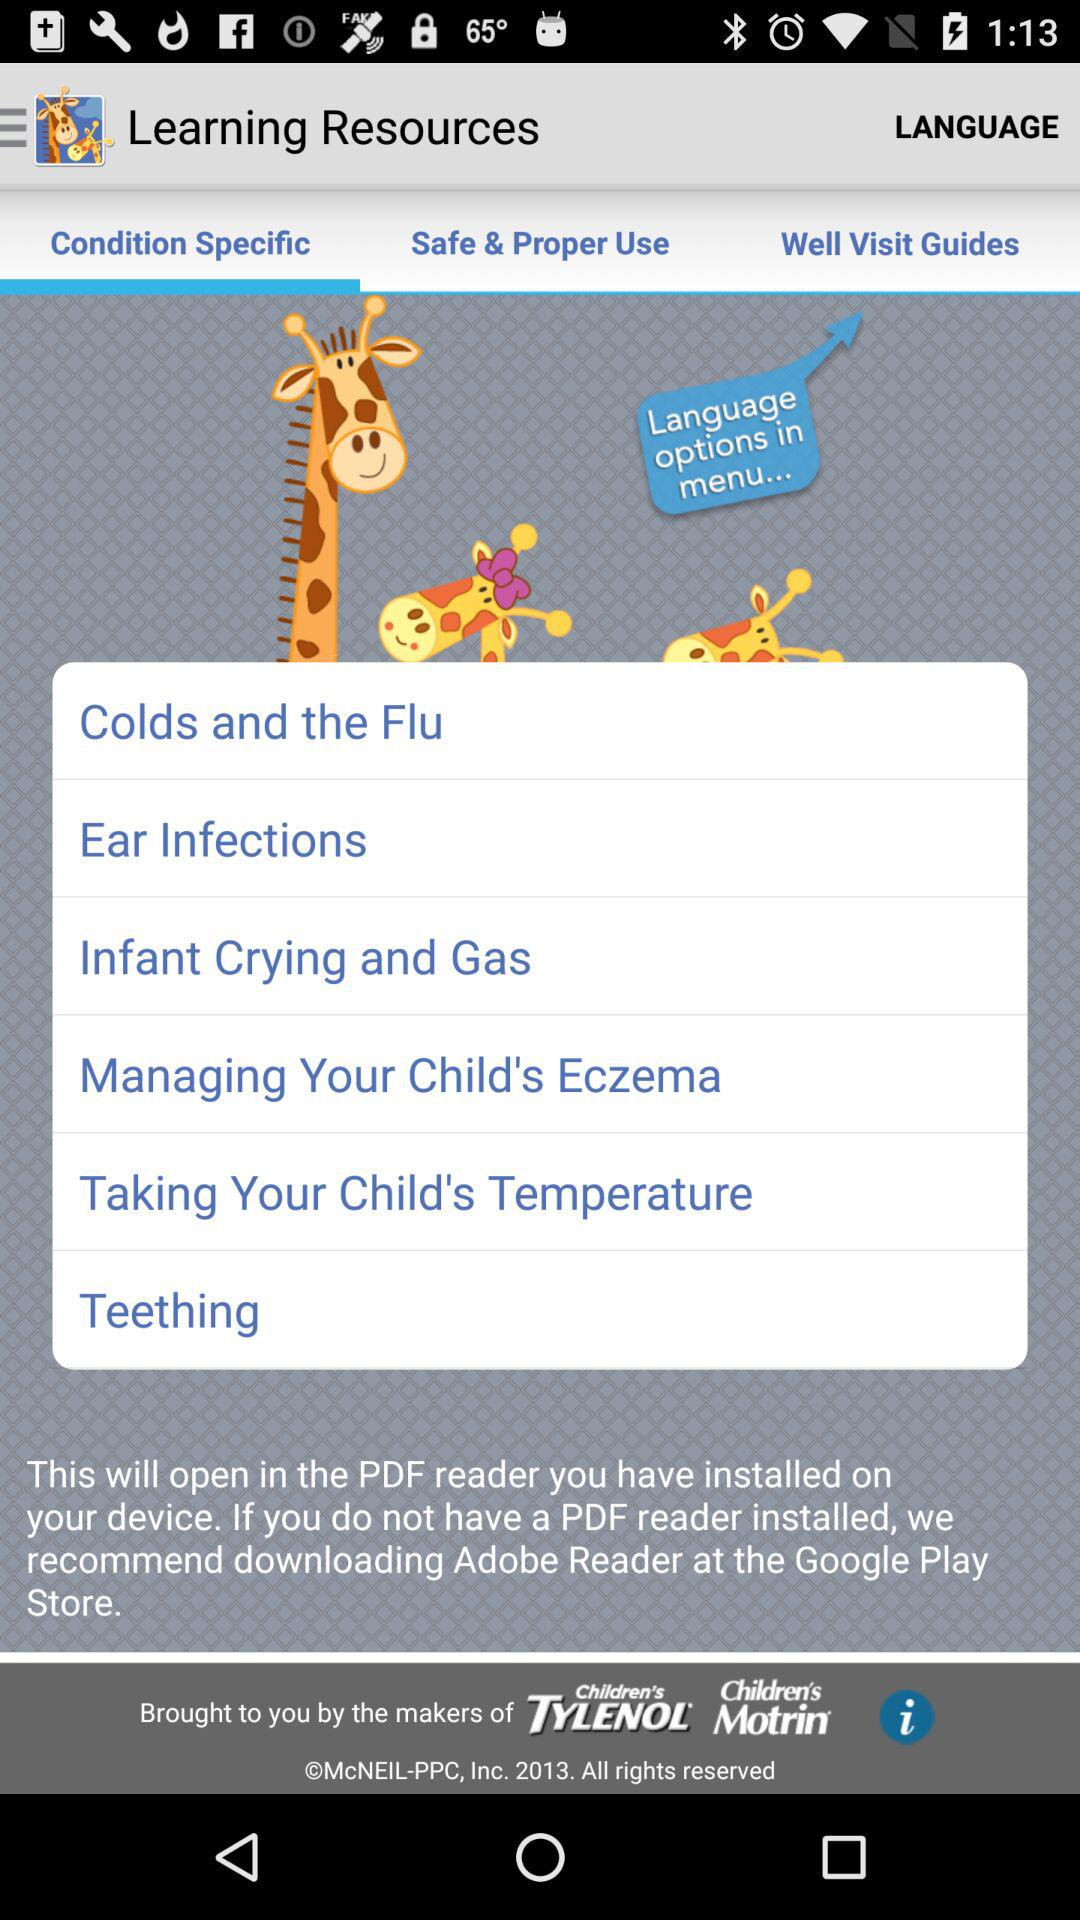What is the selected tab? The selected tab is "Condition Specific". 